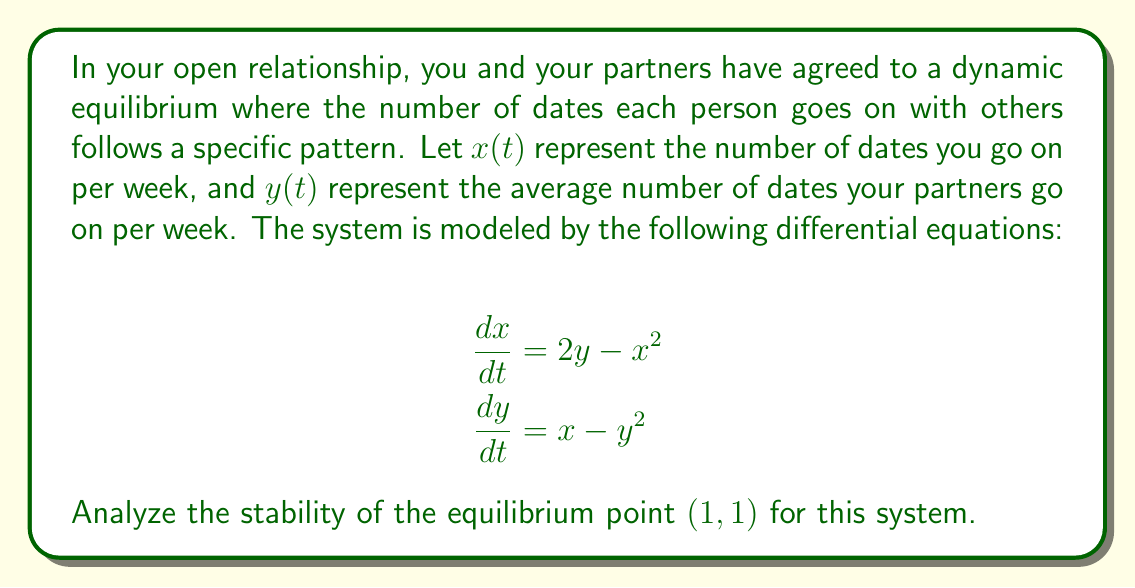Give your solution to this math problem. To analyze the stability of the equilibrium point $(1,1)$, we'll follow these steps:

1. Verify the equilibrium point:
   Substitute $x=1$ and $y=1$ into the equations:
   $$\frac{dx}{dt} = 2(1) - 1^2 = 1 = 0$$
   $$\frac{dy}{dt} = 1 - 1^2 = 0 = 0$$
   This confirms $(1,1)$ is an equilibrium point.

2. Linearize the system around the equilibrium point:
   Calculate the Jacobian matrix:
   $$J = \begin{bmatrix}
   \frac{\partial}{\partial x}(2y-x^2) & \frac{\partial}{\partial y}(2y-x^2) \\
   \frac{\partial}{\partial x}(x-y^2) & \frac{\partial}{\partial y}(x-y^2)
   \end{bmatrix}
   = \begin{bmatrix}
   -2x & 2 \\
   1 & -2y
   \end{bmatrix}$$

3. Evaluate the Jacobian at the equilibrium point $(1,1)$:
   $$J_{(1,1)} = \begin{bmatrix}
   -2 & 2 \\
   1 & -2
   \end{bmatrix}$$

4. Find the eigenvalues of $J_{(1,1)}$:
   Characteristic equation: $\det(J_{(1,1)} - \lambda I) = 0$
   $$\begin{vmatrix}
   -2-\lambda & 2 \\
   1 & -2-\lambda
   \end{vmatrix} = 0$$
   $$(-2-\lambda)^2 - 2 = 0$$
   $$\lambda^2 + 4\lambda + 2 = 0$$

   Solving this quadratic equation:
   $$\lambda = \frac{-4 \pm \sqrt{16-8}}{2} = -2 \pm \sqrt{2}$$

5. Analyze the eigenvalues:
   $\lambda_1 = -2 + \sqrt{2} \approx -0.59$ (negative real part)
   $\lambda_2 = -2 - \sqrt{2} \approx -3.41$ (negative real part)

   Since both eigenvalues have negative real parts, the equilibrium point $(1,1)$ is asymptotically stable.
Answer: Asymptotically stable 